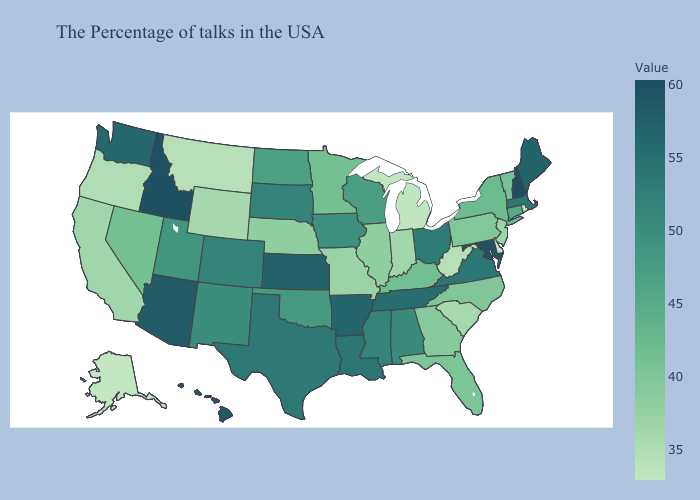Among the states that border Louisiana , does Texas have the lowest value?
Keep it brief. No. Does Wisconsin have the highest value in the MidWest?
Give a very brief answer. No. Does Kansas have the lowest value in the USA?
Be succinct. No. Does Kansas have the highest value in the MidWest?
Be succinct. Yes. Does New Hampshire have the highest value in the USA?
Short answer required. Yes. Does Massachusetts have a higher value than Maryland?
Concise answer only. No. 